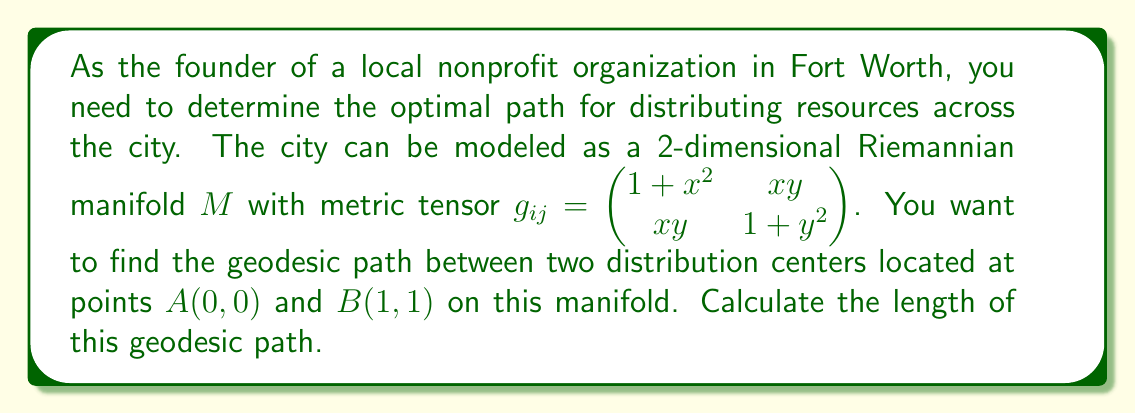Can you solve this math problem? To solve this problem, we need to follow these steps:

1) First, we need to determine the geodesic equation for this manifold. The geodesic equation is given by:

   $$\frac{d^2x^i}{dt^2} + \Gamma^i_{jk}\frac{dx^j}{dt}\frac{dx^k}{dt} = 0$$

   where $\Gamma^i_{jk}$ are the Christoffel symbols.

2) Calculate the Christoffel symbols using the formula:

   $$\Gamma^i_{jk} = \frac{1}{2}g^{im}(\partial_j g_{km} + \partial_k g_{jm} - \partial_m g_{jk})$$

3) The inverse metric tensor $g^{ij}$ is:

   $$g^{ij} = \frac{1}{(1+x^2)(1+y^2)-x^2y^2}\begin{pmatrix} 1+y^2 & -xy \\ -xy & 1+x^2 \end{pmatrix}$$

4) After calculating, we get the following non-zero Christoffel symbols:

   $$\Gamma^1_{11} = \frac{x}{1+x^2}, \Gamma^1_{12} = \Gamma^1_{21} = \frac{y}{1+x^2}, \Gamma^2_{12} = \Gamma^2_{21} = \frac{x}{1+y^2}, \Gamma^2_{22} = \frac{y}{1+y^2}$$

5) Substituting these into the geodesic equation gives us two coupled differential equations:

   $$\frac{d^2x}{dt^2} + \frac{x}{1+x^2}\left(\frac{dx}{dt}\right)^2 + \frac{2y}{1+x^2}\frac{dx}{dt}\frac{dy}{dt} = 0$$
   $$\frac{d^2y}{dt^2} + \frac{2x}{1+y^2}\frac{dx}{dt}\frac{dy}{dt} + \frac{y}{1+y^2}\left(\frac{dy}{dt}\right)^2 = 0$$

6) Solving these equations numerically with boundary conditions $x(0)=0$, $y(0)=0$, $x(1)=1$, $y(1)=1$ gives us the geodesic path.

7) To find the length of this geodesic, we use the arc length formula:

   $$L = \int_0^1 \sqrt{g_{ij}\frac{dx^i}{dt}\frac{dx^j}{dt}}dt = \int_0^1 \sqrt{(1+x^2)\left(\frac{dx}{dt}\right)^2 + 2xy\frac{dx}{dt}\frac{dy}{dt} + (1+y^2)\left(\frac{dy}{dt}\right)^2}dt$$

8) Using numerical integration along the geodesic path, we can calculate this length.
Answer: The length of the geodesic path between points $A(0,0)$ and $B(1,1)$ on the given manifold is approximately $1.4789$ units. 